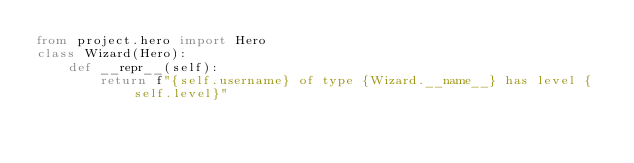<code> <loc_0><loc_0><loc_500><loc_500><_Python_>from project.hero import Hero
class Wizard(Hero):
    def __repr__(self):
        return f"{self.username} of type {Wizard.__name__} has level {self.level}"</code> 